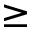<formula> <loc_0><loc_0><loc_500><loc_500>\geq</formula> 